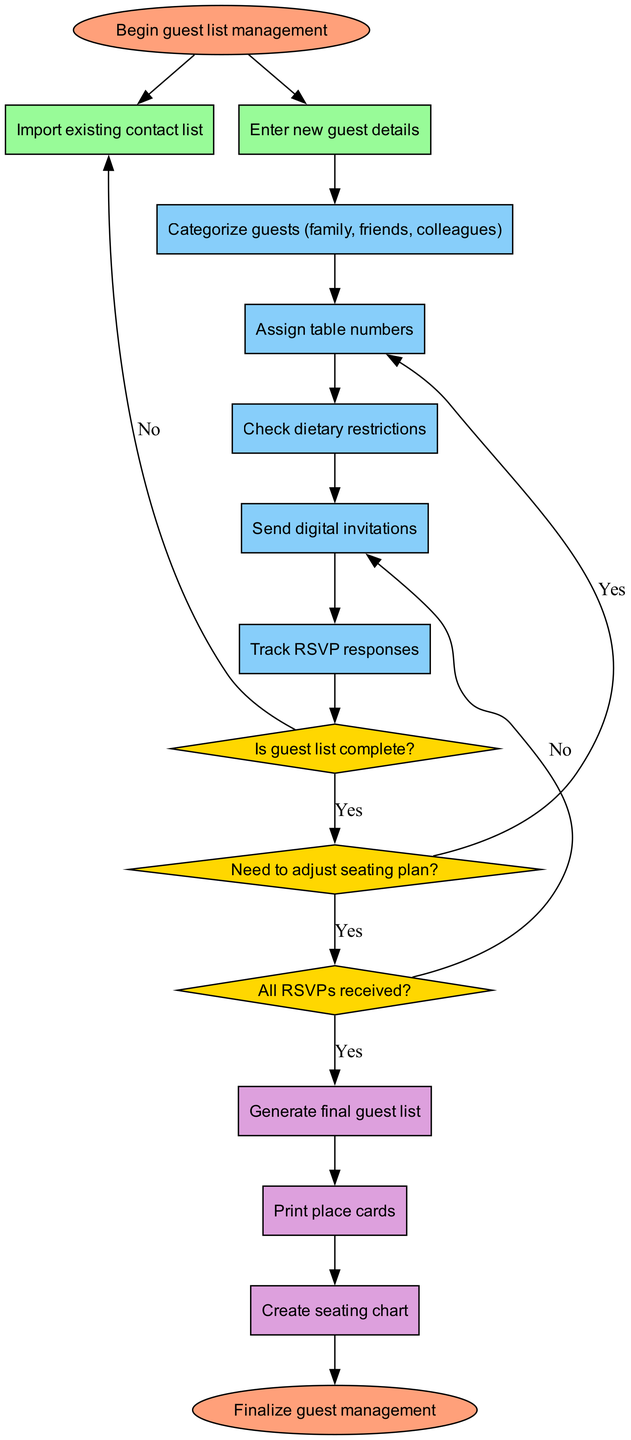What is the first input in the diagram? The first input node indicates the action of importing an existing contact list. It is the first item listed under the inputs section in the data provided.
Answer: Import existing contact list How many processes are in the diagram? The diagram lists five distinct processes pertaining to guest list management. We can count them as we go through the "processes" section of the data.
Answer: 5 What is the final output before reaching the end? The last output node mentioned in the diagram is "Create seating chart," as it is the final item listed under the outputs section.
Answer: Create seating chart If the guest list is not complete, what step occurs next? The flowchart indicates that if the guest list is not complete (as determined by the first decision node), it loops back to the first input step to import the existing contact list again.
Answer: Import existing contact list Which node handles checking dietary restrictions? The node "Check dietary restrictions" is one of the processes and is reached after categorizing guests. It is the third process listed in the diagram.
Answer: Check dietary restrictions What happens if all RSVPs are not received? If all RSVPs are not received according to the decision node, the flowchart indicates that the process loops back to one of the earlier steps, specifically to the "Send digital invitations" process.
Answer: Send digital invitations What are the two outputs that follow after tracking RSVP responses? After tracking RSVP responses, the process leads to the generation of the final guest list and printing of place cards as the next two outputs in sequence.
Answer: Generate final guest list, Print place cards Is there a decision point in the diagram before sending digital invitations? Yes, the diagram includes decision points that assess whether the guest list is complete and whether adjustments to the seating plan are needed prior to sending digital invitations.
Answer: Yes How many decision points are present in the diagram? There are three decision nodes depicted in the diagram, which evaluate different conditions related to guest list management. This can be confirmed by reviewing the "decisions" section.
Answer: 3 